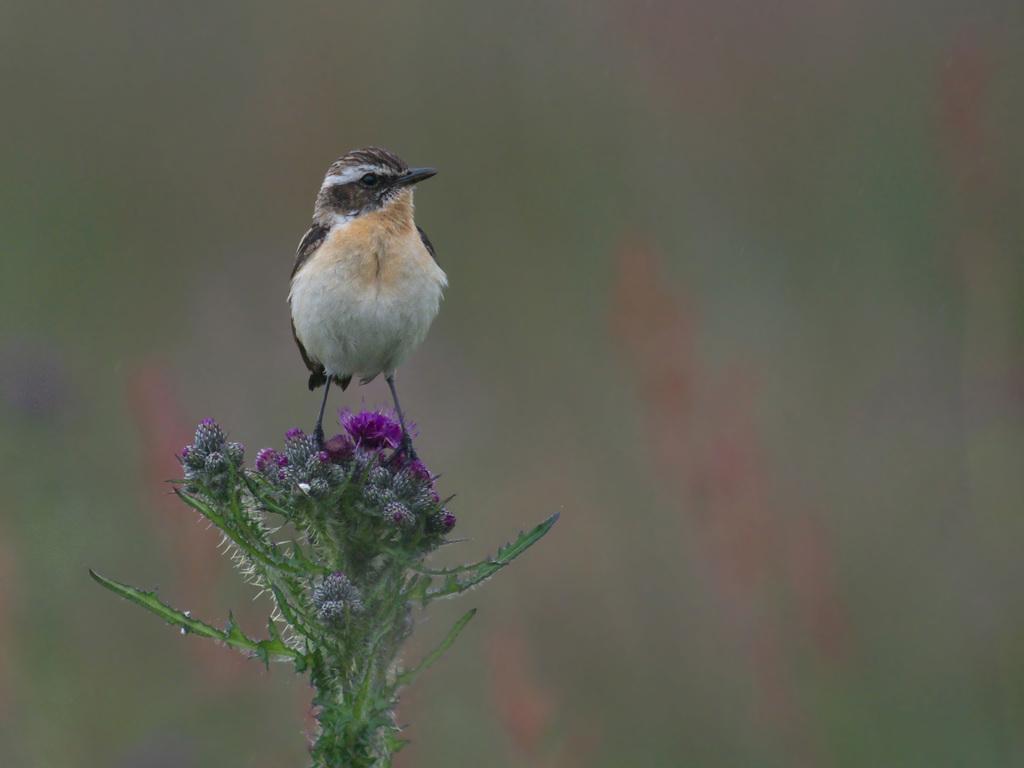Please provide a concise description of this image. In this image in the front there is a bird standing on the flowers and the background is blurry. 